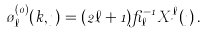<formula> <loc_0><loc_0><loc_500><loc_500>\tau _ { \ell } ^ { ( 0 ) } ( k , \eta ) = ( 2 \ell + 1 ) \beta _ { \ell } ^ { - 1 } X _ { \nu } ^ { \ell } ( \eta ) \, .</formula> 